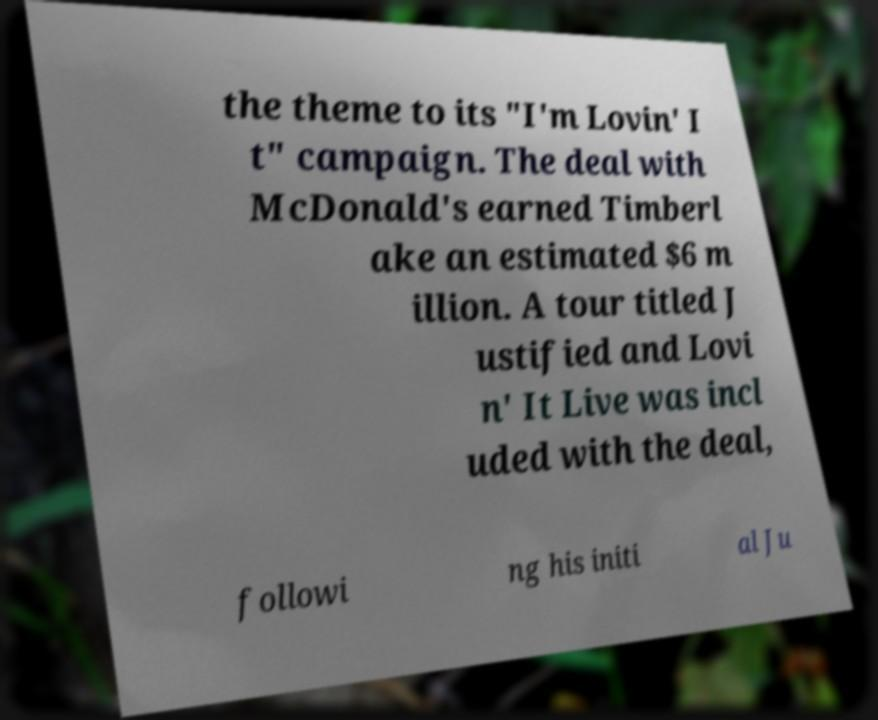Could you extract and type out the text from this image? the theme to its "I'm Lovin' I t" campaign. The deal with McDonald's earned Timberl ake an estimated $6 m illion. A tour titled J ustified and Lovi n' It Live was incl uded with the deal, followi ng his initi al Ju 